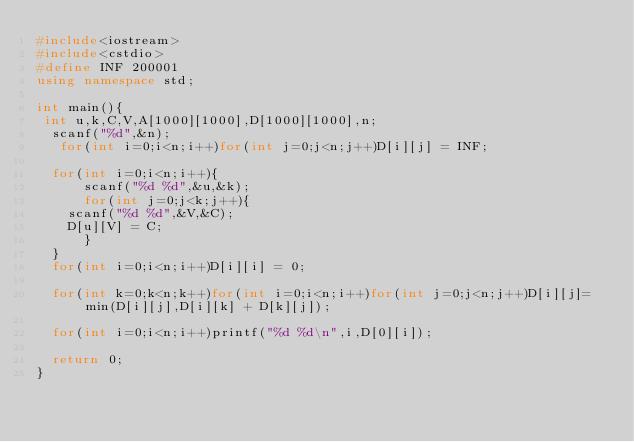<code> <loc_0><loc_0><loc_500><loc_500><_C++_>#include<iostream>
#include<cstdio>
#define INF 200001 
using namespace std;
  
int main(){
 int u,k,C,V,A[1000][1000],D[1000][1000],n;
  scanf("%d",&n);
   for(int i=0;i<n;i++)for(int j=0;j<n;j++)D[i][j] = INF;
   
  for(int i=0;i<n;i++){
      scanf("%d %d",&u,&k);    
      for(int j=0;j<k;j++){
    scanf("%d %d",&V,&C);
    D[u][V] = C;
      }    
  }
  for(int i=0;i<n;i++)D[i][i] = 0;
 
  for(int k=0;k<n;k++)for(int i=0;i<n;i++)for(int j=0;j<n;j++)D[i][j]= min(D[i][j],D[i][k] + D[k][j]);
 
  for(int i=0;i<n;i++)printf("%d %d\n",i,D[0][i]);
  
  return 0;
}</code> 